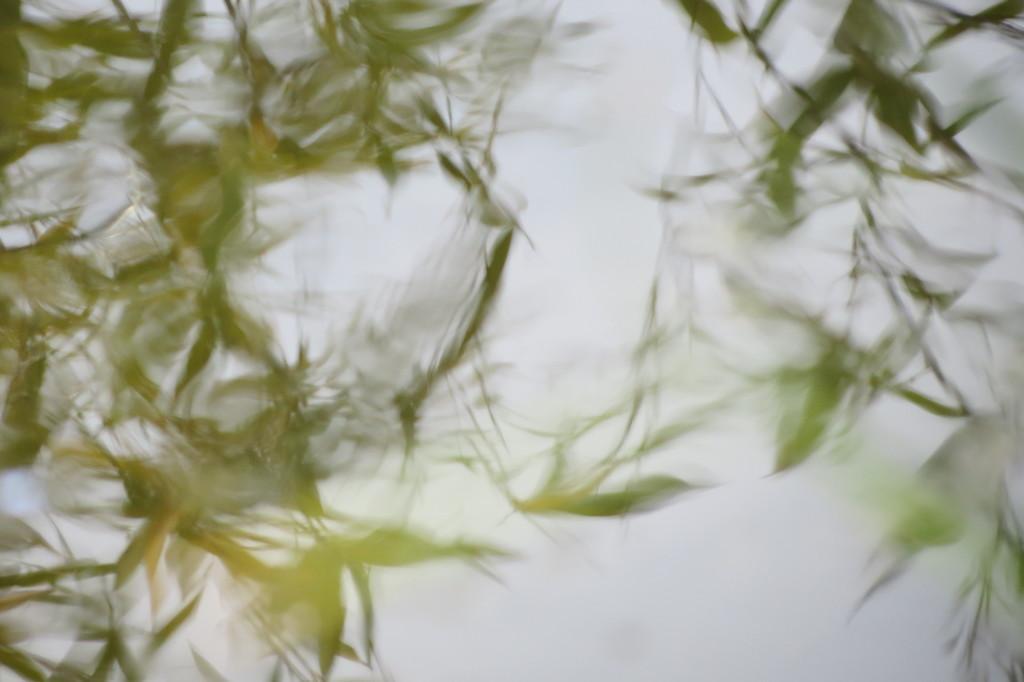How would you summarize this image in a sentence or two? In this picture we observe many leaves. 